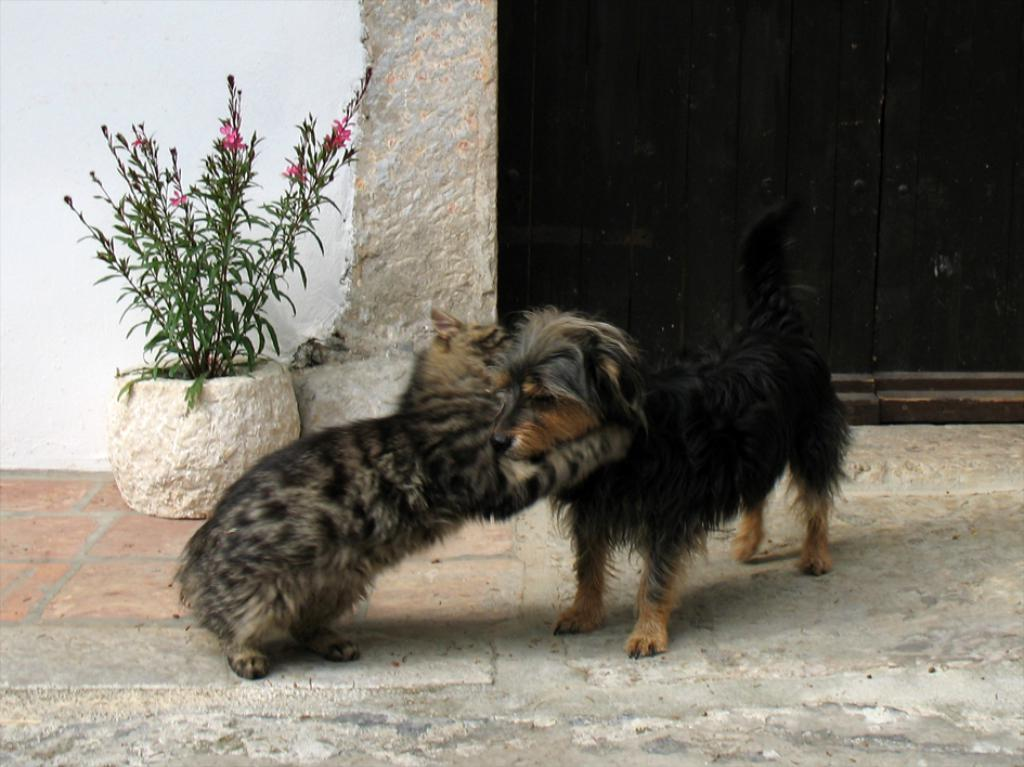What type of animal can be seen in the image? There is a dog in the image. Can you describe the position of the animal in the image? There is an animal on the ground in the image. What other object can be seen in the image? There is a house plant in the image. What can be seen in the background of the image? There is a wall visible in the background of the image. What type of appliance is being used to show respect to the dog in the image? There is no appliance present in the image, and the concept of showing respect to the dog is not mentioned or depicted. 